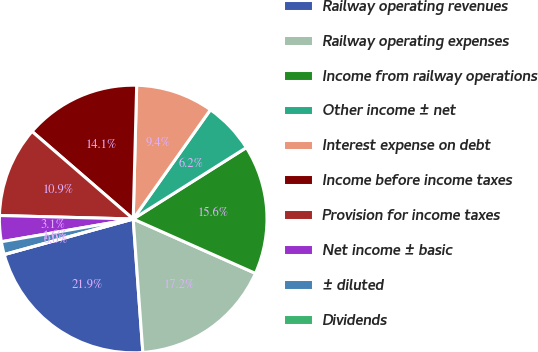Convert chart to OTSL. <chart><loc_0><loc_0><loc_500><loc_500><pie_chart><fcel>Railway operating revenues<fcel>Railway operating expenses<fcel>Income from railway operations<fcel>Other income ± net<fcel>Interest expense on debt<fcel>Income before income taxes<fcel>Provision for income taxes<fcel>Net income ± basic<fcel>± diluted<fcel>Dividends<nl><fcel>21.87%<fcel>17.19%<fcel>15.62%<fcel>6.25%<fcel>9.38%<fcel>14.06%<fcel>10.94%<fcel>3.13%<fcel>1.56%<fcel>0.0%<nl></chart> 